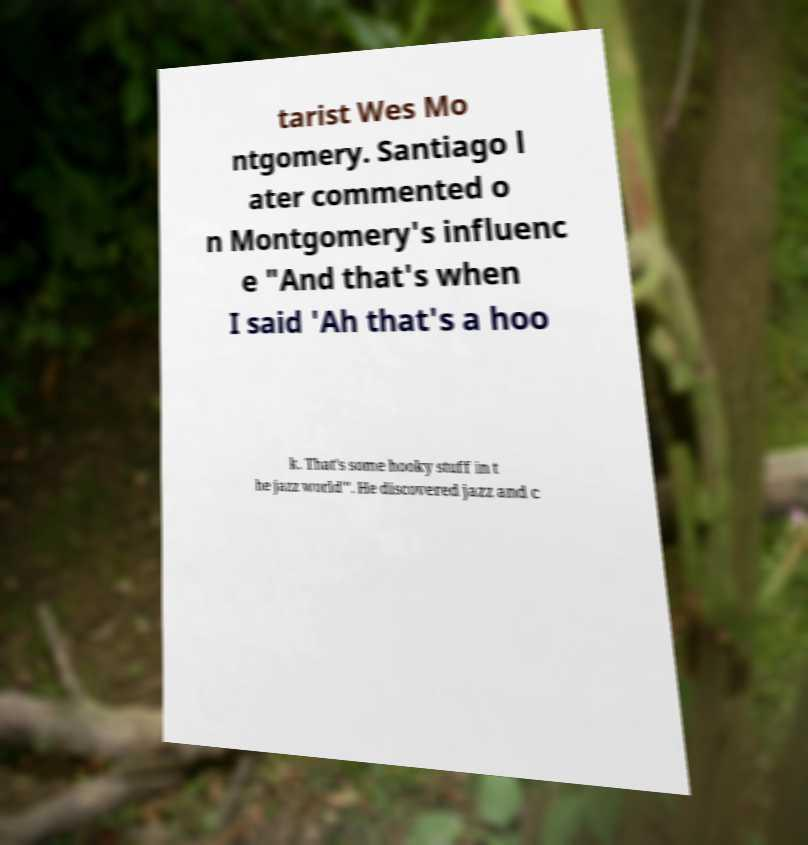There's text embedded in this image that I need extracted. Can you transcribe it verbatim? tarist Wes Mo ntgomery. Santiago l ater commented o n Montgomery's influenc e "And that's when I said 'Ah that's a hoo k. That's some hooky stuff in t he jazz world'". He discovered jazz and c 